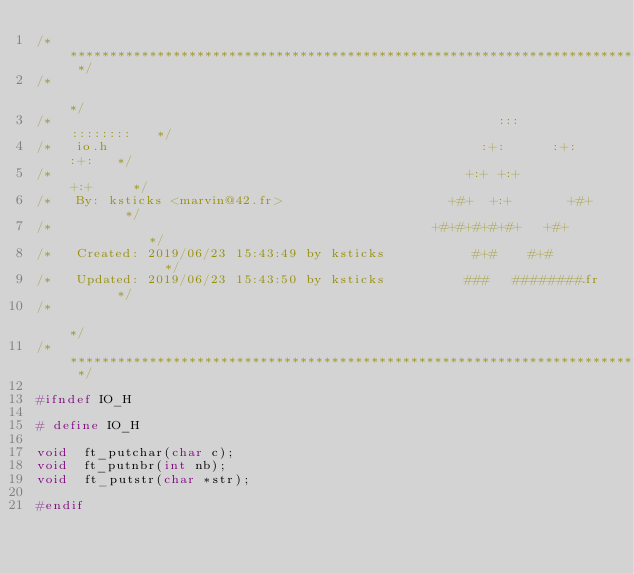Convert code to text. <code><loc_0><loc_0><loc_500><loc_500><_C_>/* ************************************************************************** */
/*                                                                            */
/*                                                        :::      ::::::::   */
/*   io.h                                               :+:      :+:    :+:   */
/*                                                    +:+ +:+         +:+     */
/*   By: ksticks <marvin@42.fr>                     +#+  +:+       +#+        */
/*                                                +#+#+#+#+#+   +#+           */
/*   Created: 2019/06/23 15:43:49 by ksticks           #+#    #+#             */
/*   Updated: 2019/06/23 15:43:50 by ksticks          ###   ########.fr       */
/*                                                                            */
/* ************************************************************************** */

#ifndef IO_H

# define IO_H

void	ft_putchar(char c);
void	ft_putnbr(int nb);
void	ft_putstr(char *str);

#endif
</code> 